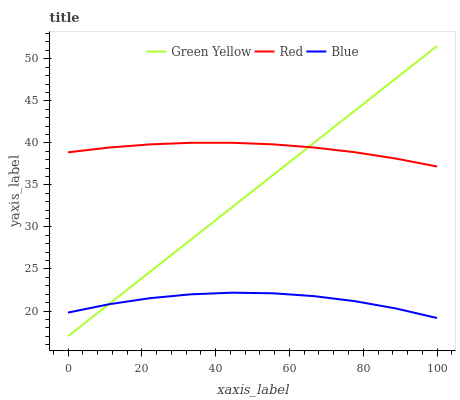Does Blue have the minimum area under the curve?
Answer yes or no. Yes. Does Red have the maximum area under the curve?
Answer yes or no. Yes. Does Green Yellow have the minimum area under the curve?
Answer yes or no. No. Does Green Yellow have the maximum area under the curve?
Answer yes or no. No. Is Green Yellow the smoothest?
Answer yes or no. Yes. Is Blue the roughest?
Answer yes or no. Yes. Is Red the smoothest?
Answer yes or no. No. Is Red the roughest?
Answer yes or no. No. Does Green Yellow have the lowest value?
Answer yes or no. Yes. Does Red have the lowest value?
Answer yes or no. No. Does Green Yellow have the highest value?
Answer yes or no. Yes. Does Red have the highest value?
Answer yes or no. No. Is Blue less than Red?
Answer yes or no. Yes. Is Red greater than Blue?
Answer yes or no. Yes. Does Blue intersect Green Yellow?
Answer yes or no. Yes. Is Blue less than Green Yellow?
Answer yes or no. No. Is Blue greater than Green Yellow?
Answer yes or no. No. Does Blue intersect Red?
Answer yes or no. No. 